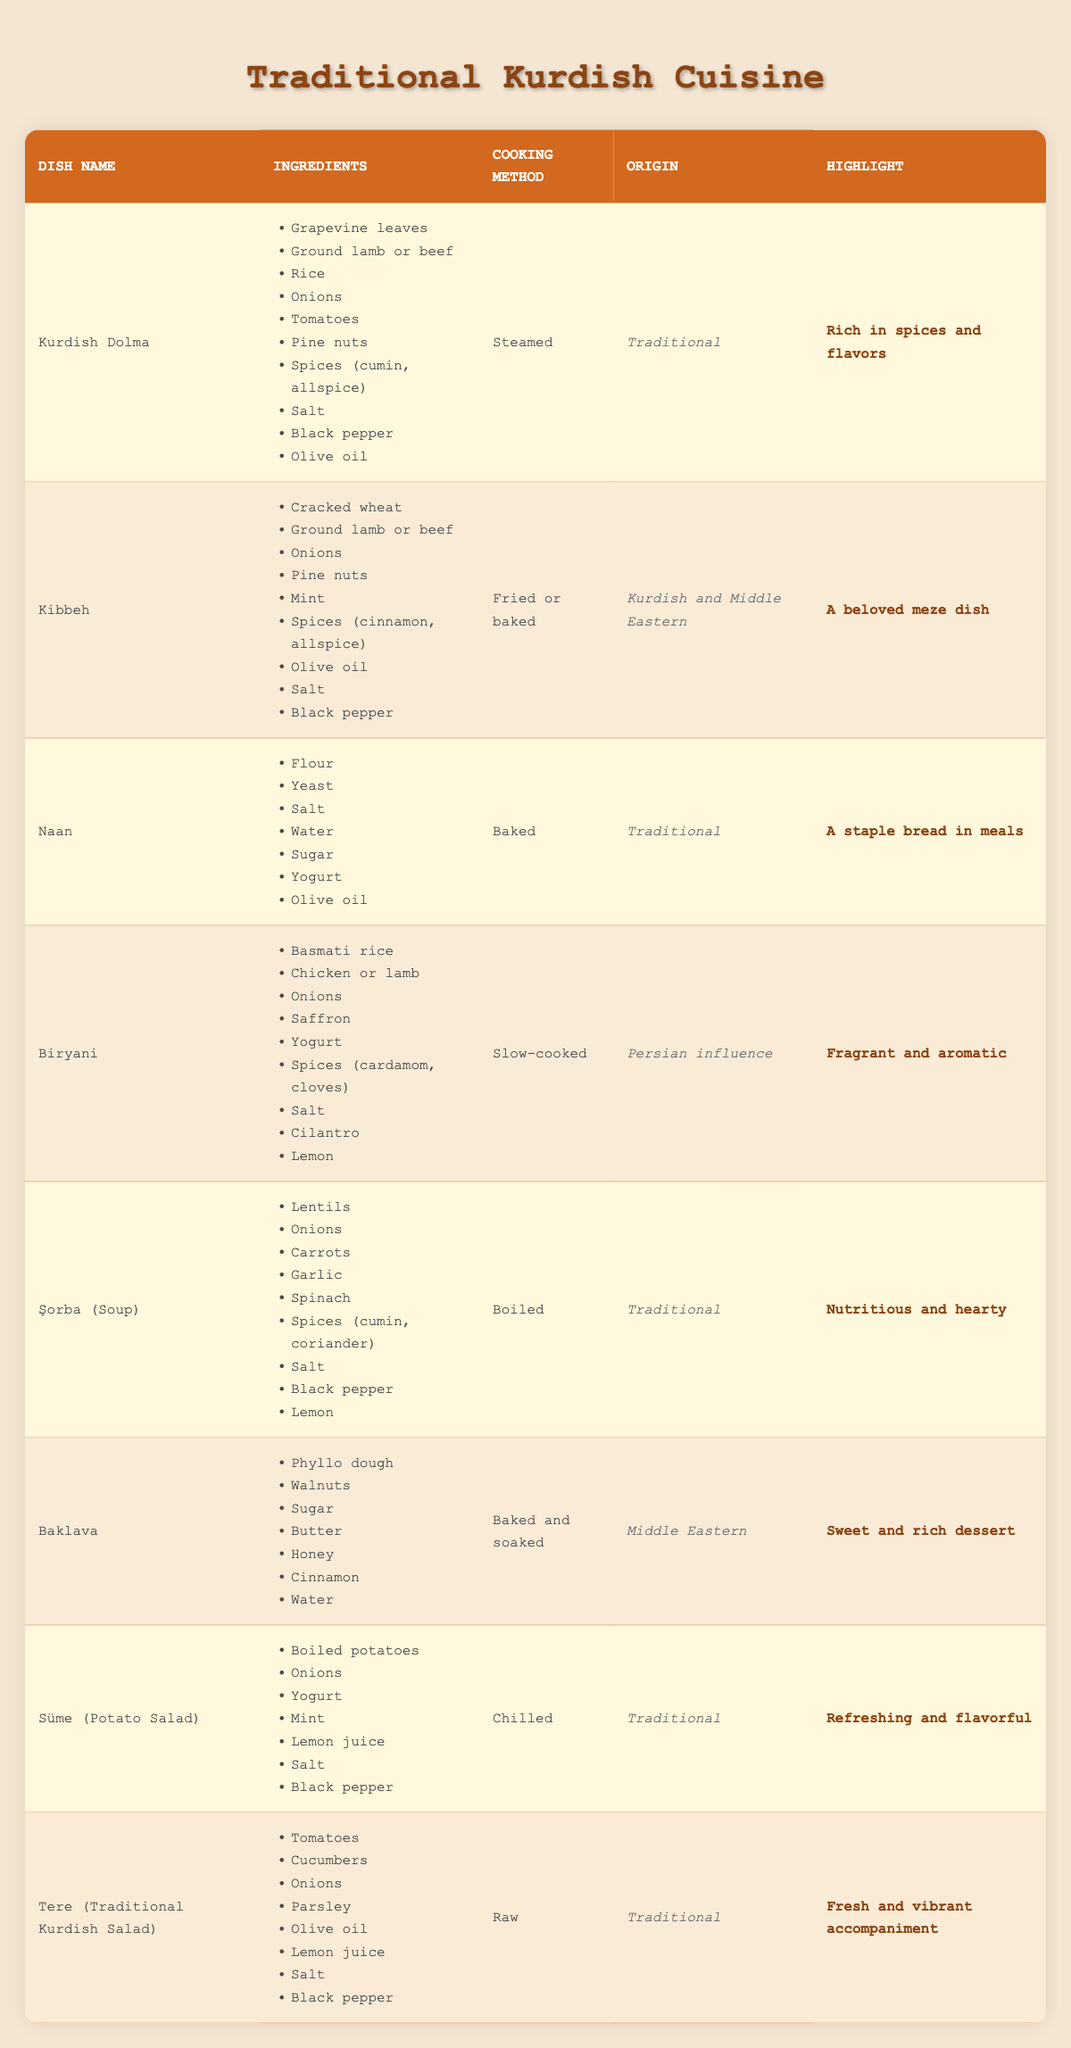What dish uses grapevine leaves as an ingredient? By scanning the table, I see that "Kurdish Dolma" lists "Grapevine leaves" among its ingredients.
Answer: Kurdish Dolma Which dish is highlighted as "A beloved meze dish"? The table indicates that "Kibbeh" has the highlight stating "A beloved meze dish".
Answer: Kibbeh What is the main cooking method for Biryani? The table shows that Biryani is cooked using the method described as "Slow-cooked".
Answer: Slow-cooked Does Baklava contain walnuts? According to the ingredients listed for Baklava, it indeed includes "Walnuts".
Answer: Yes Which dish has the origin categorized as "Traditional"? Looking at the origin column, "Kurdish Dolma", "Naan", "Şorba", "Süme", and "Tere" are listed with the origin as "Traditional".
Answer: Kurdish Dolma, Naan, Şorba, Süme, Tere What is the total number of dishes that can be prepared by baking? By checking the cooking methods in the table, I find that "Kibbeh", "Naan", "Baklava", and "Biryani" can be classified as baking, totaling 4 dishes.
Answer: 4 Which dish requires mint in its preparation? The ingredients for "Kibbeh" and "Süme" both list "Mint" as an ingredient.
Answer: Kibbeh, Süme What makes Şorba particularly notable according to the table? The highlight for Şorba states "Nutritious and hearty", which specifies its notable characteristic.
Answer: Nutritious and hearty How many dishes on the table are traditionally raw? By reviewing the cooking methods, only "Tere" is categorized as raw, leading to a total of 1 dish that fits this criterion.
Answer: 1 Are there any dishes that include both olive oil and lemon juice? The dishes "Tere" and "Süme" include both "Olive oil" and "Lemon juice" in their ingredients.
Answer: Tere, Süme Which dish has the ingredient saffron and what is its cooking method? "Biryani" lists "Saffron" as one of its ingredients and is cooked "Slow-cooked".
Answer: Biryani, Slow-cooked What is the highlight associated with the dish Naan? The highlight listed for Naan in the table is "A staple bread in meals".
Answer: A staple bread in meals What are the ingredients for Kurdish Dolma? The dish "Kurdish Dolma" includes grapevine leaves, ground lamb or beef, rice, onions, tomatoes, pine nuts, various spices, salt, black pepper, and olive oil.
Answer: Grape leaves, ground lamb or beef, rice, onions, tomatoes, pine nuts, spices, salt, black pepper, olive oil Is there a dish that prominently features phyllo dough? Yes, "Baklava" is the dish in the table that lists "Phyllo dough" as one of its main ingredients.
Answer: Yes Which dish includes carrots and what is its cooking method? The dish "Şorba" contains "Carrots" and its cooking method is "Boiled".
Answer: Şorba, Boiled 